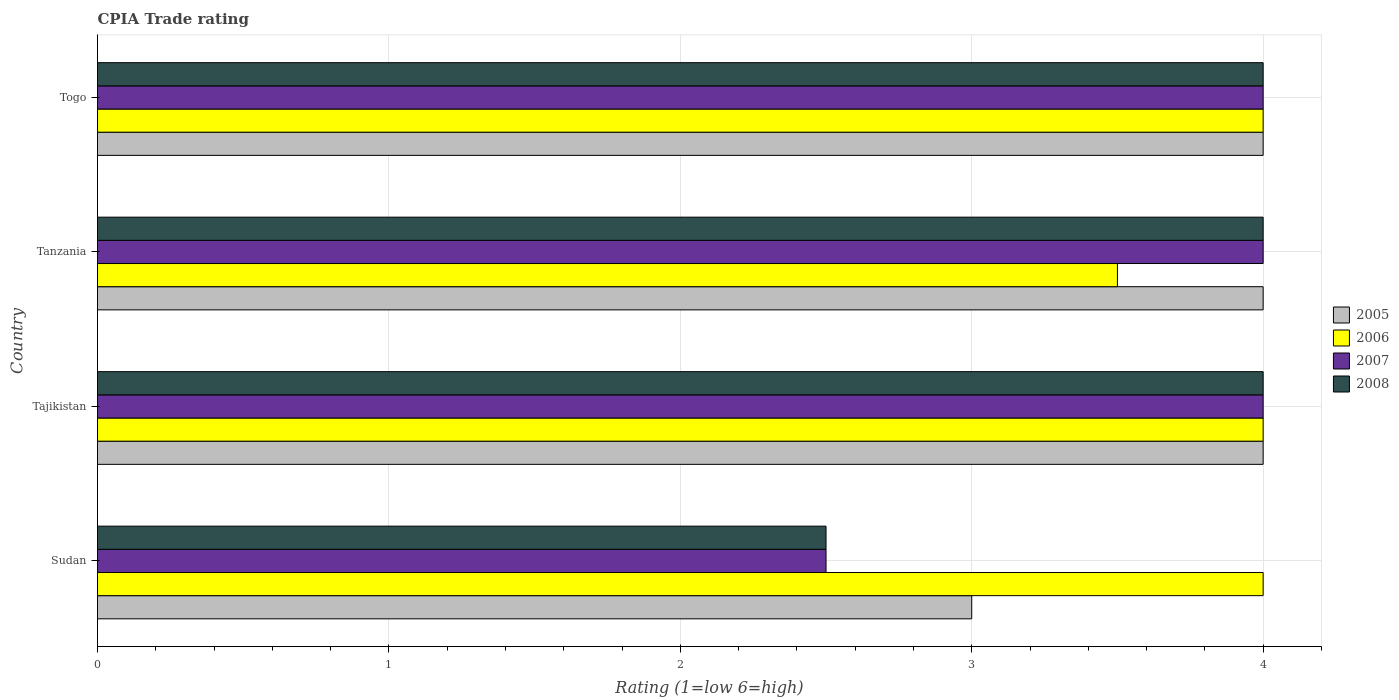How many groups of bars are there?
Your response must be concise. 4. How many bars are there on the 1st tick from the top?
Provide a succinct answer. 4. How many bars are there on the 1st tick from the bottom?
Give a very brief answer. 4. What is the label of the 2nd group of bars from the top?
Offer a terse response. Tanzania. In how many cases, is the number of bars for a given country not equal to the number of legend labels?
Your response must be concise. 0. What is the CPIA rating in 2007 in Tanzania?
Make the answer very short. 4. In which country was the CPIA rating in 2005 maximum?
Keep it short and to the point. Tajikistan. In which country was the CPIA rating in 2005 minimum?
Make the answer very short. Sudan. What is the difference between the CPIA rating in 2008 in Sudan and the CPIA rating in 2005 in Tajikistan?
Your answer should be compact. -1.5. What is the average CPIA rating in 2008 per country?
Provide a short and direct response. 3.62. What is the ratio of the CPIA rating in 2008 in Tajikistan to that in Tanzania?
Your response must be concise. 1. Is the CPIA rating in 2006 in Sudan less than that in Tanzania?
Provide a short and direct response. No. What is the difference between the highest and the second highest CPIA rating in 2007?
Give a very brief answer. 0. In how many countries, is the CPIA rating in 2006 greater than the average CPIA rating in 2006 taken over all countries?
Your answer should be compact. 3. Is the sum of the CPIA rating in 2007 in Sudan and Togo greater than the maximum CPIA rating in 2008 across all countries?
Your answer should be very brief. Yes. Is it the case that in every country, the sum of the CPIA rating in 2005 and CPIA rating in 2006 is greater than the sum of CPIA rating in 2007 and CPIA rating in 2008?
Make the answer very short. Yes. What does the 2nd bar from the top in Togo represents?
Your answer should be compact. 2007. Is it the case that in every country, the sum of the CPIA rating in 2005 and CPIA rating in 2007 is greater than the CPIA rating in 2008?
Provide a short and direct response. Yes. How many bars are there?
Your answer should be compact. 16. What is the difference between two consecutive major ticks on the X-axis?
Make the answer very short. 1. Are the values on the major ticks of X-axis written in scientific E-notation?
Keep it short and to the point. No. Does the graph contain grids?
Your answer should be very brief. Yes. Where does the legend appear in the graph?
Keep it short and to the point. Center right. What is the title of the graph?
Offer a very short reply. CPIA Trade rating. What is the label or title of the Y-axis?
Your answer should be very brief. Country. What is the Rating (1=low 6=high) of 2005 in Sudan?
Your response must be concise. 3. What is the Rating (1=low 6=high) of 2008 in Sudan?
Provide a short and direct response. 2.5. What is the Rating (1=low 6=high) of 2005 in Tajikistan?
Keep it short and to the point. 4. What is the Rating (1=low 6=high) in 2007 in Tajikistan?
Provide a succinct answer. 4. What is the Rating (1=low 6=high) in 2008 in Tanzania?
Your answer should be very brief. 4. What is the Rating (1=low 6=high) of 2005 in Togo?
Keep it short and to the point. 4. What is the Rating (1=low 6=high) in 2006 in Togo?
Your response must be concise. 4. Across all countries, what is the maximum Rating (1=low 6=high) of 2005?
Give a very brief answer. 4. Across all countries, what is the maximum Rating (1=low 6=high) in 2007?
Give a very brief answer. 4. Across all countries, what is the minimum Rating (1=low 6=high) in 2008?
Your answer should be very brief. 2.5. What is the total Rating (1=low 6=high) of 2005 in the graph?
Your response must be concise. 15. What is the total Rating (1=low 6=high) of 2006 in the graph?
Ensure brevity in your answer.  15.5. What is the difference between the Rating (1=low 6=high) in 2005 in Sudan and that in Tajikistan?
Give a very brief answer. -1. What is the difference between the Rating (1=low 6=high) in 2006 in Sudan and that in Tajikistan?
Offer a terse response. 0. What is the difference between the Rating (1=low 6=high) of 2007 in Sudan and that in Tajikistan?
Make the answer very short. -1.5. What is the difference between the Rating (1=low 6=high) of 2008 in Sudan and that in Tajikistan?
Your answer should be compact. -1.5. What is the difference between the Rating (1=low 6=high) of 2006 in Sudan and that in Tanzania?
Ensure brevity in your answer.  0.5. What is the difference between the Rating (1=low 6=high) in 2007 in Sudan and that in Tanzania?
Provide a short and direct response. -1.5. What is the difference between the Rating (1=low 6=high) in 2008 in Sudan and that in Tanzania?
Provide a succinct answer. -1.5. What is the difference between the Rating (1=low 6=high) in 2005 in Sudan and that in Togo?
Keep it short and to the point. -1. What is the difference between the Rating (1=low 6=high) in 2006 in Sudan and that in Togo?
Your response must be concise. 0. What is the difference between the Rating (1=low 6=high) in 2007 in Sudan and that in Togo?
Your answer should be very brief. -1.5. What is the difference between the Rating (1=low 6=high) of 2008 in Sudan and that in Togo?
Provide a short and direct response. -1.5. What is the difference between the Rating (1=low 6=high) of 2006 in Tajikistan and that in Tanzania?
Provide a short and direct response. 0.5. What is the difference between the Rating (1=low 6=high) of 2007 in Tajikistan and that in Tanzania?
Your answer should be very brief. 0. What is the difference between the Rating (1=low 6=high) of 2008 in Tajikistan and that in Tanzania?
Ensure brevity in your answer.  0. What is the difference between the Rating (1=low 6=high) in 2005 in Tajikistan and that in Togo?
Provide a succinct answer. 0. What is the difference between the Rating (1=low 6=high) in 2006 in Tajikistan and that in Togo?
Give a very brief answer. 0. What is the difference between the Rating (1=low 6=high) of 2008 in Tajikistan and that in Togo?
Give a very brief answer. 0. What is the difference between the Rating (1=low 6=high) of 2007 in Tanzania and that in Togo?
Your answer should be compact. 0. What is the difference between the Rating (1=low 6=high) of 2008 in Tanzania and that in Togo?
Your response must be concise. 0. What is the difference between the Rating (1=low 6=high) of 2005 in Sudan and the Rating (1=low 6=high) of 2007 in Tajikistan?
Give a very brief answer. -1. What is the difference between the Rating (1=low 6=high) in 2006 in Sudan and the Rating (1=low 6=high) in 2007 in Tajikistan?
Offer a very short reply. 0. What is the difference between the Rating (1=low 6=high) of 2005 in Sudan and the Rating (1=low 6=high) of 2007 in Tanzania?
Provide a short and direct response. -1. What is the difference between the Rating (1=low 6=high) in 2005 in Sudan and the Rating (1=low 6=high) in 2008 in Tanzania?
Your answer should be very brief. -1. What is the difference between the Rating (1=low 6=high) of 2006 in Sudan and the Rating (1=low 6=high) of 2007 in Tanzania?
Offer a terse response. 0. What is the difference between the Rating (1=low 6=high) in 2005 in Sudan and the Rating (1=low 6=high) in 2006 in Togo?
Offer a very short reply. -1. What is the difference between the Rating (1=low 6=high) in 2006 in Sudan and the Rating (1=low 6=high) in 2007 in Togo?
Offer a very short reply. 0. What is the difference between the Rating (1=low 6=high) in 2006 in Sudan and the Rating (1=low 6=high) in 2008 in Togo?
Your response must be concise. 0. What is the difference between the Rating (1=low 6=high) in 2007 in Sudan and the Rating (1=low 6=high) in 2008 in Togo?
Keep it short and to the point. -1.5. What is the difference between the Rating (1=low 6=high) in 2005 in Tajikistan and the Rating (1=low 6=high) in 2008 in Tanzania?
Provide a short and direct response. 0. What is the difference between the Rating (1=low 6=high) of 2006 in Tajikistan and the Rating (1=low 6=high) of 2007 in Tanzania?
Your answer should be very brief. 0. What is the difference between the Rating (1=low 6=high) of 2006 in Tajikistan and the Rating (1=low 6=high) of 2008 in Tanzania?
Provide a short and direct response. 0. What is the difference between the Rating (1=low 6=high) in 2007 in Tajikistan and the Rating (1=low 6=high) in 2008 in Tanzania?
Ensure brevity in your answer.  0. What is the difference between the Rating (1=low 6=high) in 2005 in Tajikistan and the Rating (1=low 6=high) in 2007 in Togo?
Keep it short and to the point. 0. What is the difference between the Rating (1=low 6=high) in 2005 in Tajikistan and the Rating (1=low 6=high) in 2008 in Togo?
Keep it short and to the point. 0. What is the difference between the Rating (1=low 6=high) in 2006 in Tajikistan and the Rating (1=low 6=high) in 2007 in Togo?
Provide a succinct answer. 0. What is the difference between the Rating (1=low 6=high) of 2006 in Tajikistan and the Rating (1=low 6=high) of 2008 in Togo?
Provide a short and direct response. 0. What is the difference between the Rating (1=low 6=high) of 2007 in Tajikistan and the Rating (1=low 6=high) of 2008 in Togo?
Offer a very short reply. 0. What is the average Rating (1=low 6=high) in 2005 per country?
Give a very brief answer. 3.75. What is the average Rating (1=low 6=high) of 2006 per country?
Offer a very short reply. 3.88. What is the average Rating (1=low 6=high) of 2007 per country?
Your answer should be compact. 3.62. What is the average Rating (1=low 6=high) of 2008 per country?
Provide a succinct answer. 3.62. What is the difference between the Rating (1=low 6=high) of 2005 and Rating (1=low 6=high) of 2006 in Sudan?
Offer a very short reply. -1. What is the difference between the Rating (1=low 6=high) of 2005 and Rating (1=low 6=high) of 2007 in Sudan?
Offer a terse response. 0.5. What is the difference between the Rating (1=low 6=high) in 2005 and Rating (1=low 6=high) in 2008 in Sudan?
Offer a terse response. 0.5. What is the difference between the Rating (1=low 6=high) of 2006 and Rating (1=low 6=high) of 2007 in Sudan?
Make the answer very short. 1.5. What is the difference between the Rating (1=low 6=high) in 2007 and Rating (1=low 6=high) in 2008 in Sudan?
Make the answer very short. 0. What is the difference between the Rating (1=low 6=high) of 2005 and Rating (1=low 6=high) of 2006 in Tajikistan?
Make the answer very short. 0. What is the difference between the Rating (1=low 6=high) in 2005 and Rating (1=low 6=high) in 2007 in Tajikistan?
Provide a short and direct response. 0. What is the difference between the Rating (1=low 6=high) of 2006 and Rating (1=low 6=high) of 2007 in Tajikistan?
Keep it short and to the point. 0. What is the difference between the Rating (1=low 6=high) in 2006 and Rating (1=low 6=high) in 2007 in Tanzania?
Ensure brevity in your answer.  -0.5. What is the difference between the Rating (1=low 6=high) of 2007 and Rating (1=low 6=high) of 2008 in Tanzania?
Ensure brevity in your answer.  0. What is the difference between the Rating (1=low 6=high) of 2005 and Rating (1=low 6=high) of 2007 in Togo?
Make the answer very short. 0. What is the ratio of the Rating (1=low 6=high) of 2005 in Sudan to that in Tajikistan?
Your answer should be very brief. 0.75. What is the ratio of the Rating (1=low 6=high) of 2006 in Sudan to that in Tajikistan?
Provide a short and direct response. 1. What is the ratio of the Rating (1=low 6=high) in 2007 in Sudan to that in Tajikistan?
Keep it short and to the point. 0.62. What is the ratio of the Rating (1=low 6=high) of 2006 in Sudan to that in Tanzania?
Offer a very short reply. 1.14. What is the ratio of the Rating (1=low 6=high) of 2008 in Sudan to that in Tanzania?
Make the answer very short. 0.62. What is the ratio of the Rating (1=low 6=high) in 2005 in Sudan to that in Togo?
Provide a succinct answer. 0.75. What is the ratio of the Rating (1=low 6=high) in 2005 in Tajikistan to that in Tanzania?
Your answer should be very brief. 1. What is the ratio of the Rating (1=low 6=high) of 2006 in Tajikistan to that in Tanzania?
Offer a very short reply. 1.14. What is the ratio of the Rating (1=low 6=high) of 2008 in Tajikistan to that in Tanzania?
Your response must be concise. 1. What is the ratio of the Rating (1=low 6=high) of 2005 in Tanzania to that in Togo?
Offer a terse response. 1. What is the ratio of the Rating (1=low 6=high) in 2006 in Tanzania to that in Togo?
Ensure brevity in your answer.  0.88. What is the difference between the highest and the second highest Rating (1=low 6=high) of 2006?
Make the answer very short. 0. What is the difference between the highest and the lowest Rating (1=low 6=high) of 2006?
Provide a succinct answer. 0.5. What is the difference between the highest and the lowest Rating (1=low 6=high) of 2008?
Keep it short and to the point. 1.5. 